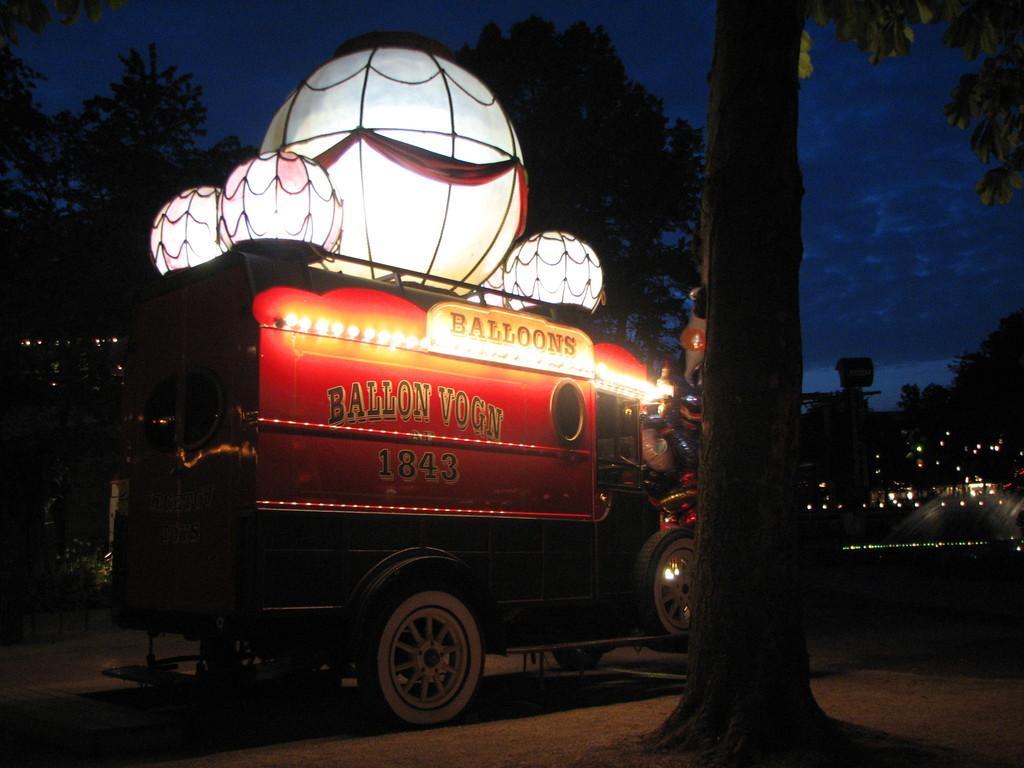Describe this image in one or two sentences. In this image we can see there is a vehicle on the road. On the top of a vehicle there are balloons, beside the vehicle there is a tree. 